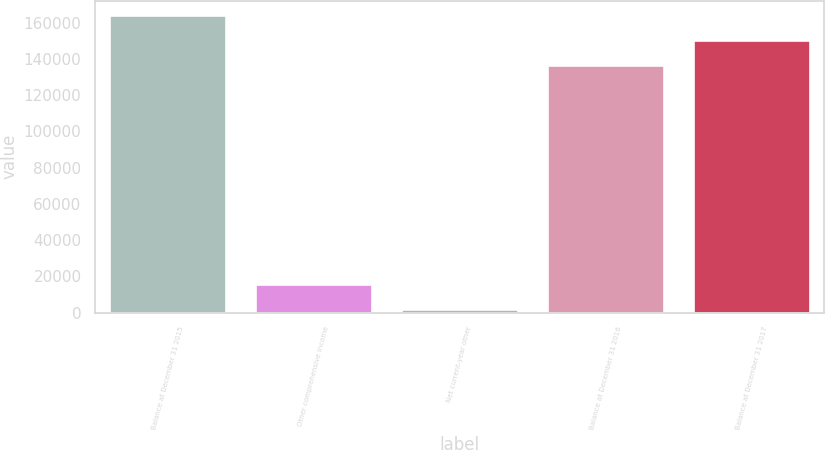Convert chart. <chart><loc_0><loc_0><loc_500><loc_500><bar_chart><fcel>Balance at December 31 2015<fcel>Other comprehensive income<fcel>Net current-year other<fcel>Balance at December 31 2016<fcel>Balance at December 31 2017<nl><fcel>163931<fcel>15879.5<fcel>2212<fcel>136596<fcel>150264<nl></chart> 